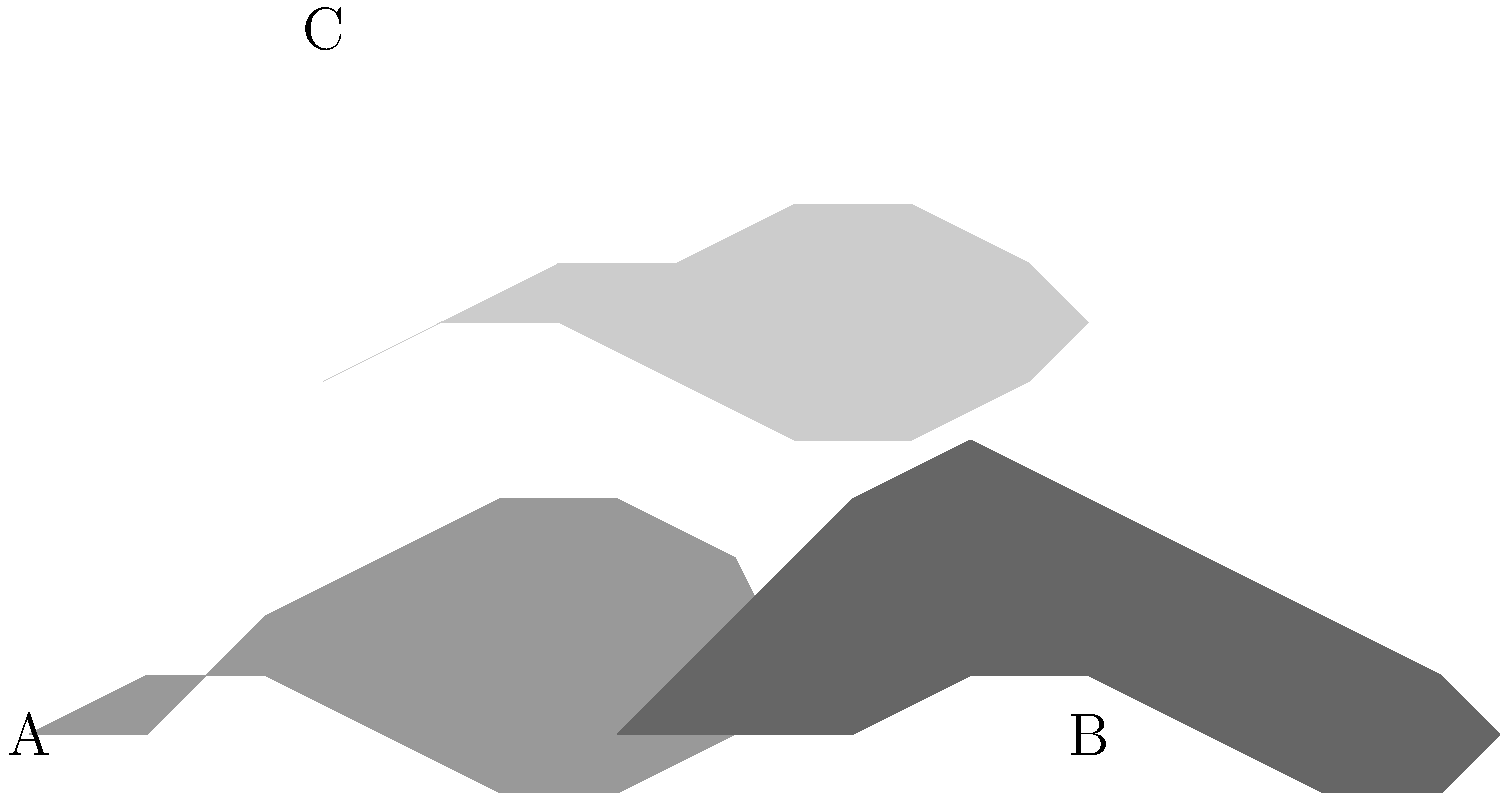As a wildlife trafficking expert, identify which of the silhouettes (A, B, or C) represents a rhinoceros, a species heavily targeted by poachers for its horn. How can you distinguish this silhouette from the others? To identify the rhinoceros silhouette and distinguish it from the others, follow these steps:

1. Analyze the distinctive features of each silhouette:
   A: Has a prominent horn-like protrusion on the snout and a relatively compact body.
   B: Shows a long trunk-like extension and large, flappy ears.
   C: Displays a sleek body with a long tail and no prominent facial features.

2. Consider the characteristics of a rhinoceros:
   - Large, bulky body
   - Distinctive horn on the snout
   - Short, thick legs
   - Small ears

3. Compare the silhouettes to these characteristics:
   A: Matches the rhinoceros description with its horn and bulky body.
   B: Resembles an elephant with its trunk and large ears.
   C: Likely represents a big cat, possibly a tiger, due to its sleek body and long tail.

4. Eliminate the non-rhinoceros options:
   B and C do not match the rhinoceros characteristics.

5. Conclude that silhouette A represents the rhinoceros.

6. Note the importance of this identification in wildlife trafficking:
   Rhinoceros horns are highly valuable in illegal wildlife trade, making accurate identification crucial for conservation efforts and anti-poaching measures.
Answer: A (Rhinoceros) 